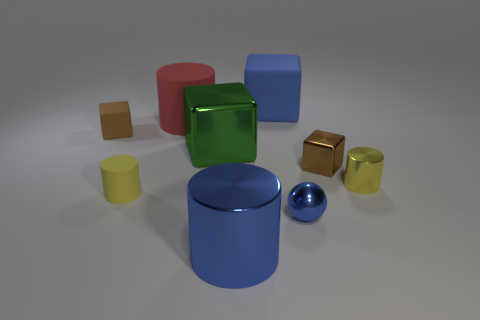Can you describe the texture visible on the red object at the back? The red object in the background appears to have a matte surface, with a subtle bumpy texture that diffuses the light, providing a contrast to the shiny surfaces of the nearby objects. 